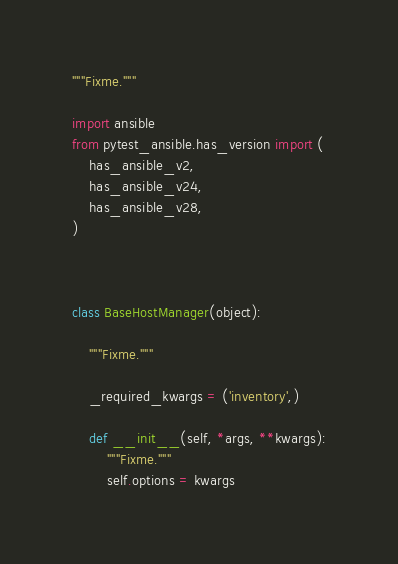<code> <loc_0><loc_0><loc_500><loc_500><_Python_>"""Fixme."""

import ansible
from pytest_ansible.has_version import (
    has_ansible_v2,
    has_ansible_v24,
    has_ansible_v28,
)



class BaseHostManager(object):

    """Fixme."""

    _required_kwargs = ('inventory',)

    def __init__(self, *args, **kwargs):
        """Fixme."""
        self.options = kwargs
</code> 